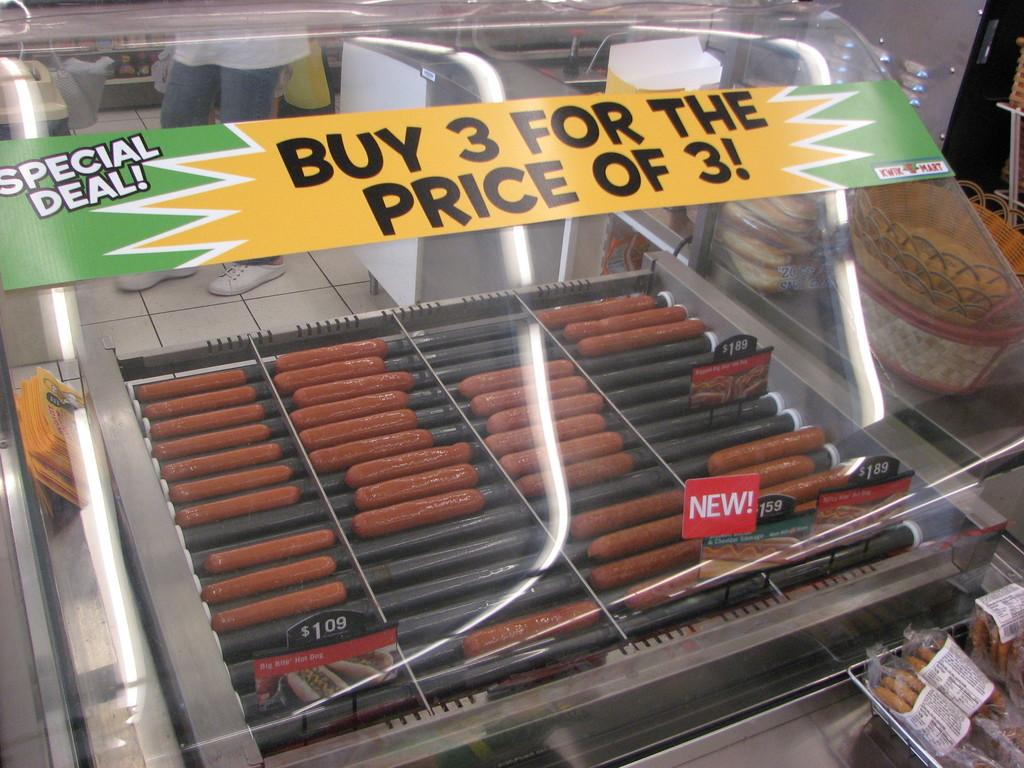What type of food can be seen in the image? There are sausages and other food items in the image. What can be used to display prices in the image? There are price boards in the image. What type of signage is present in the image? There is a poster in the image. What can be used to hold items in the image? There are baskets in the image. What can be seen in the background of the image? There are people standing and objects in the background of the image. What religious symbols can be seen in the image? There are no religious symbols present in the image. How much waste is visible in the image? There is no waste visible in the image. 